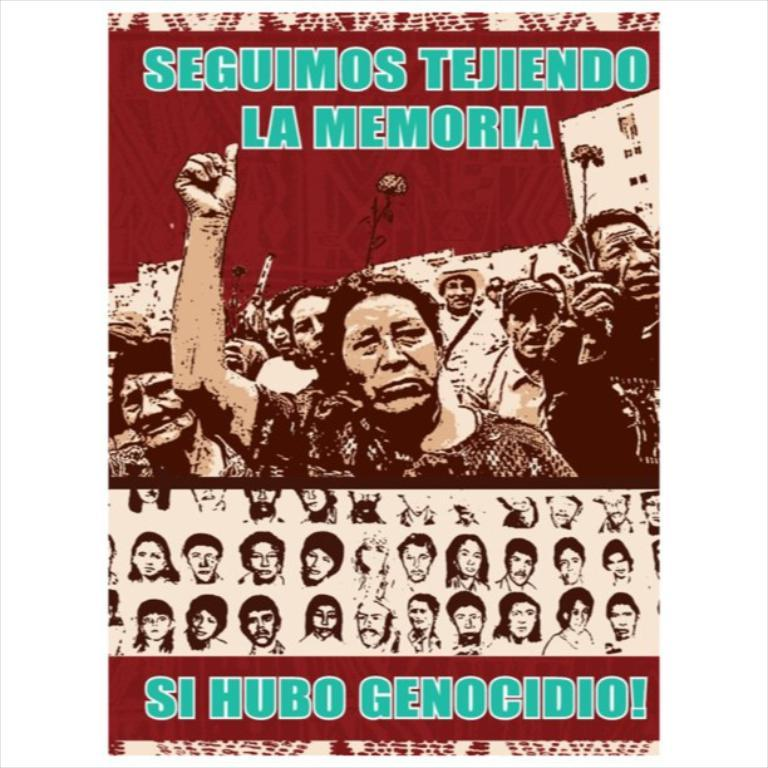What is present in the image that contains information or visuals? There is a poster in the image. What can be found on the poster besides images? The poster contains text. What type of images are on the poster? The poster contains images of persons. What color is the crayon used to draw the door on the poster? There is no crayon or door present on the poster; it contains text and images of persons. 